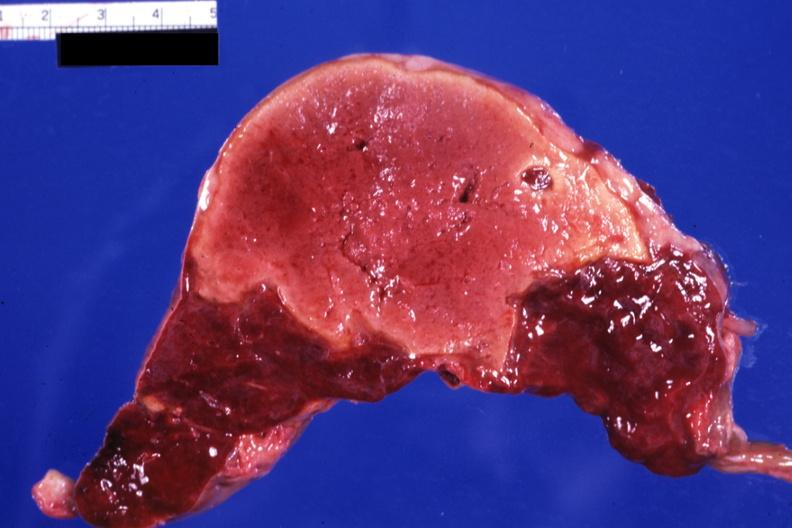what is present?
Answer the question using a single word or phrase. Spleen 